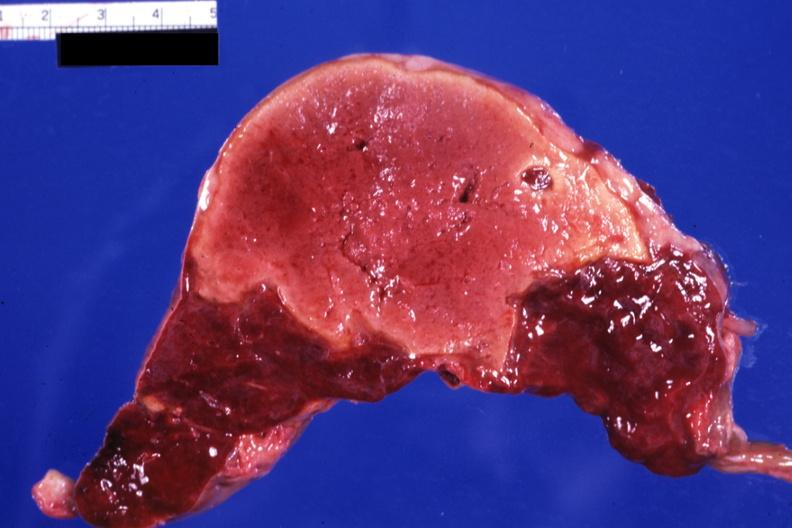what is present?
Answer the question using a single word or phrase. Spleen 